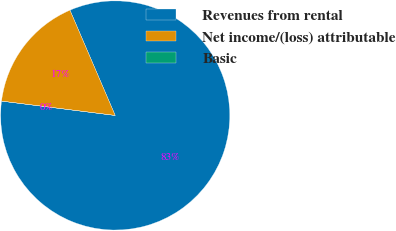<chart> <loc_0><loc_0><loc_500><loc_500><pie_chart><fcel>Revenues from rental<fcel>Net income/(loss) attributable<fcel>Basic<nl><fcel>83.46%<fcel>16.54%<fcel>0.0%<nl></chart> 